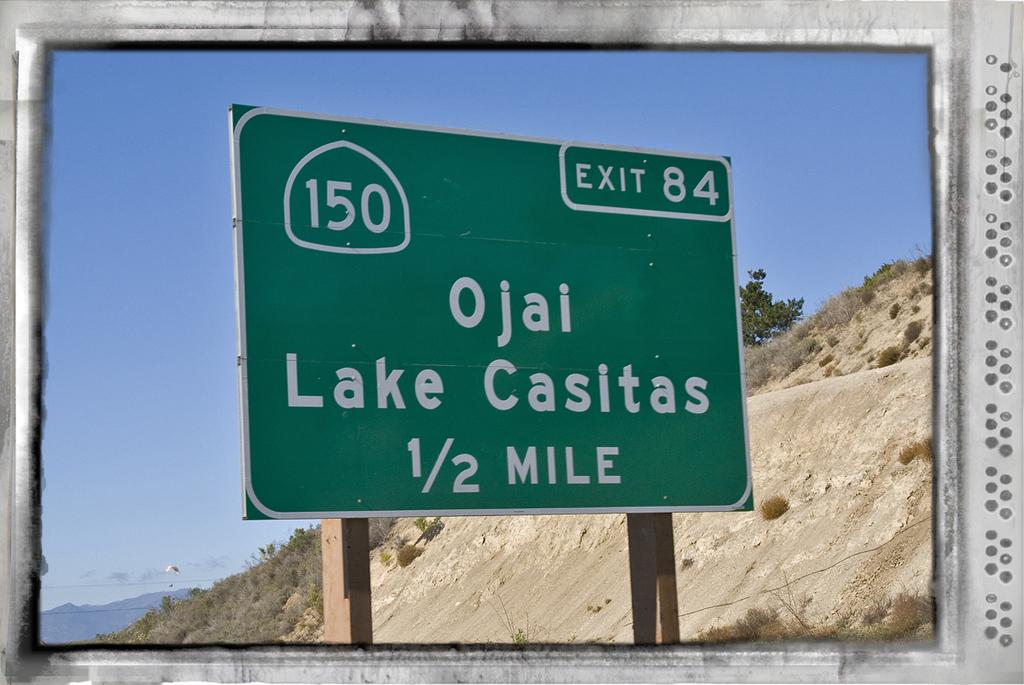<image>
Create a compact narrative representing the image presented. The green sign says that exit 84 is in half a mile. 